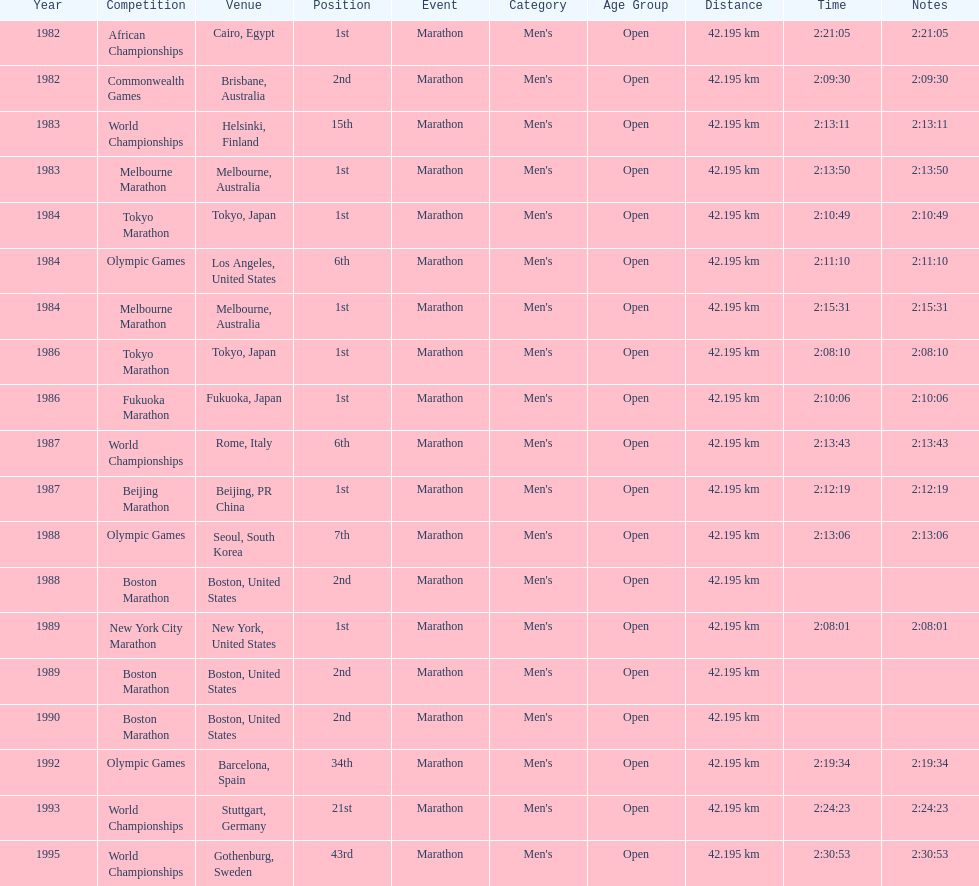What were the number of times the venue was located in the united states? 5. 